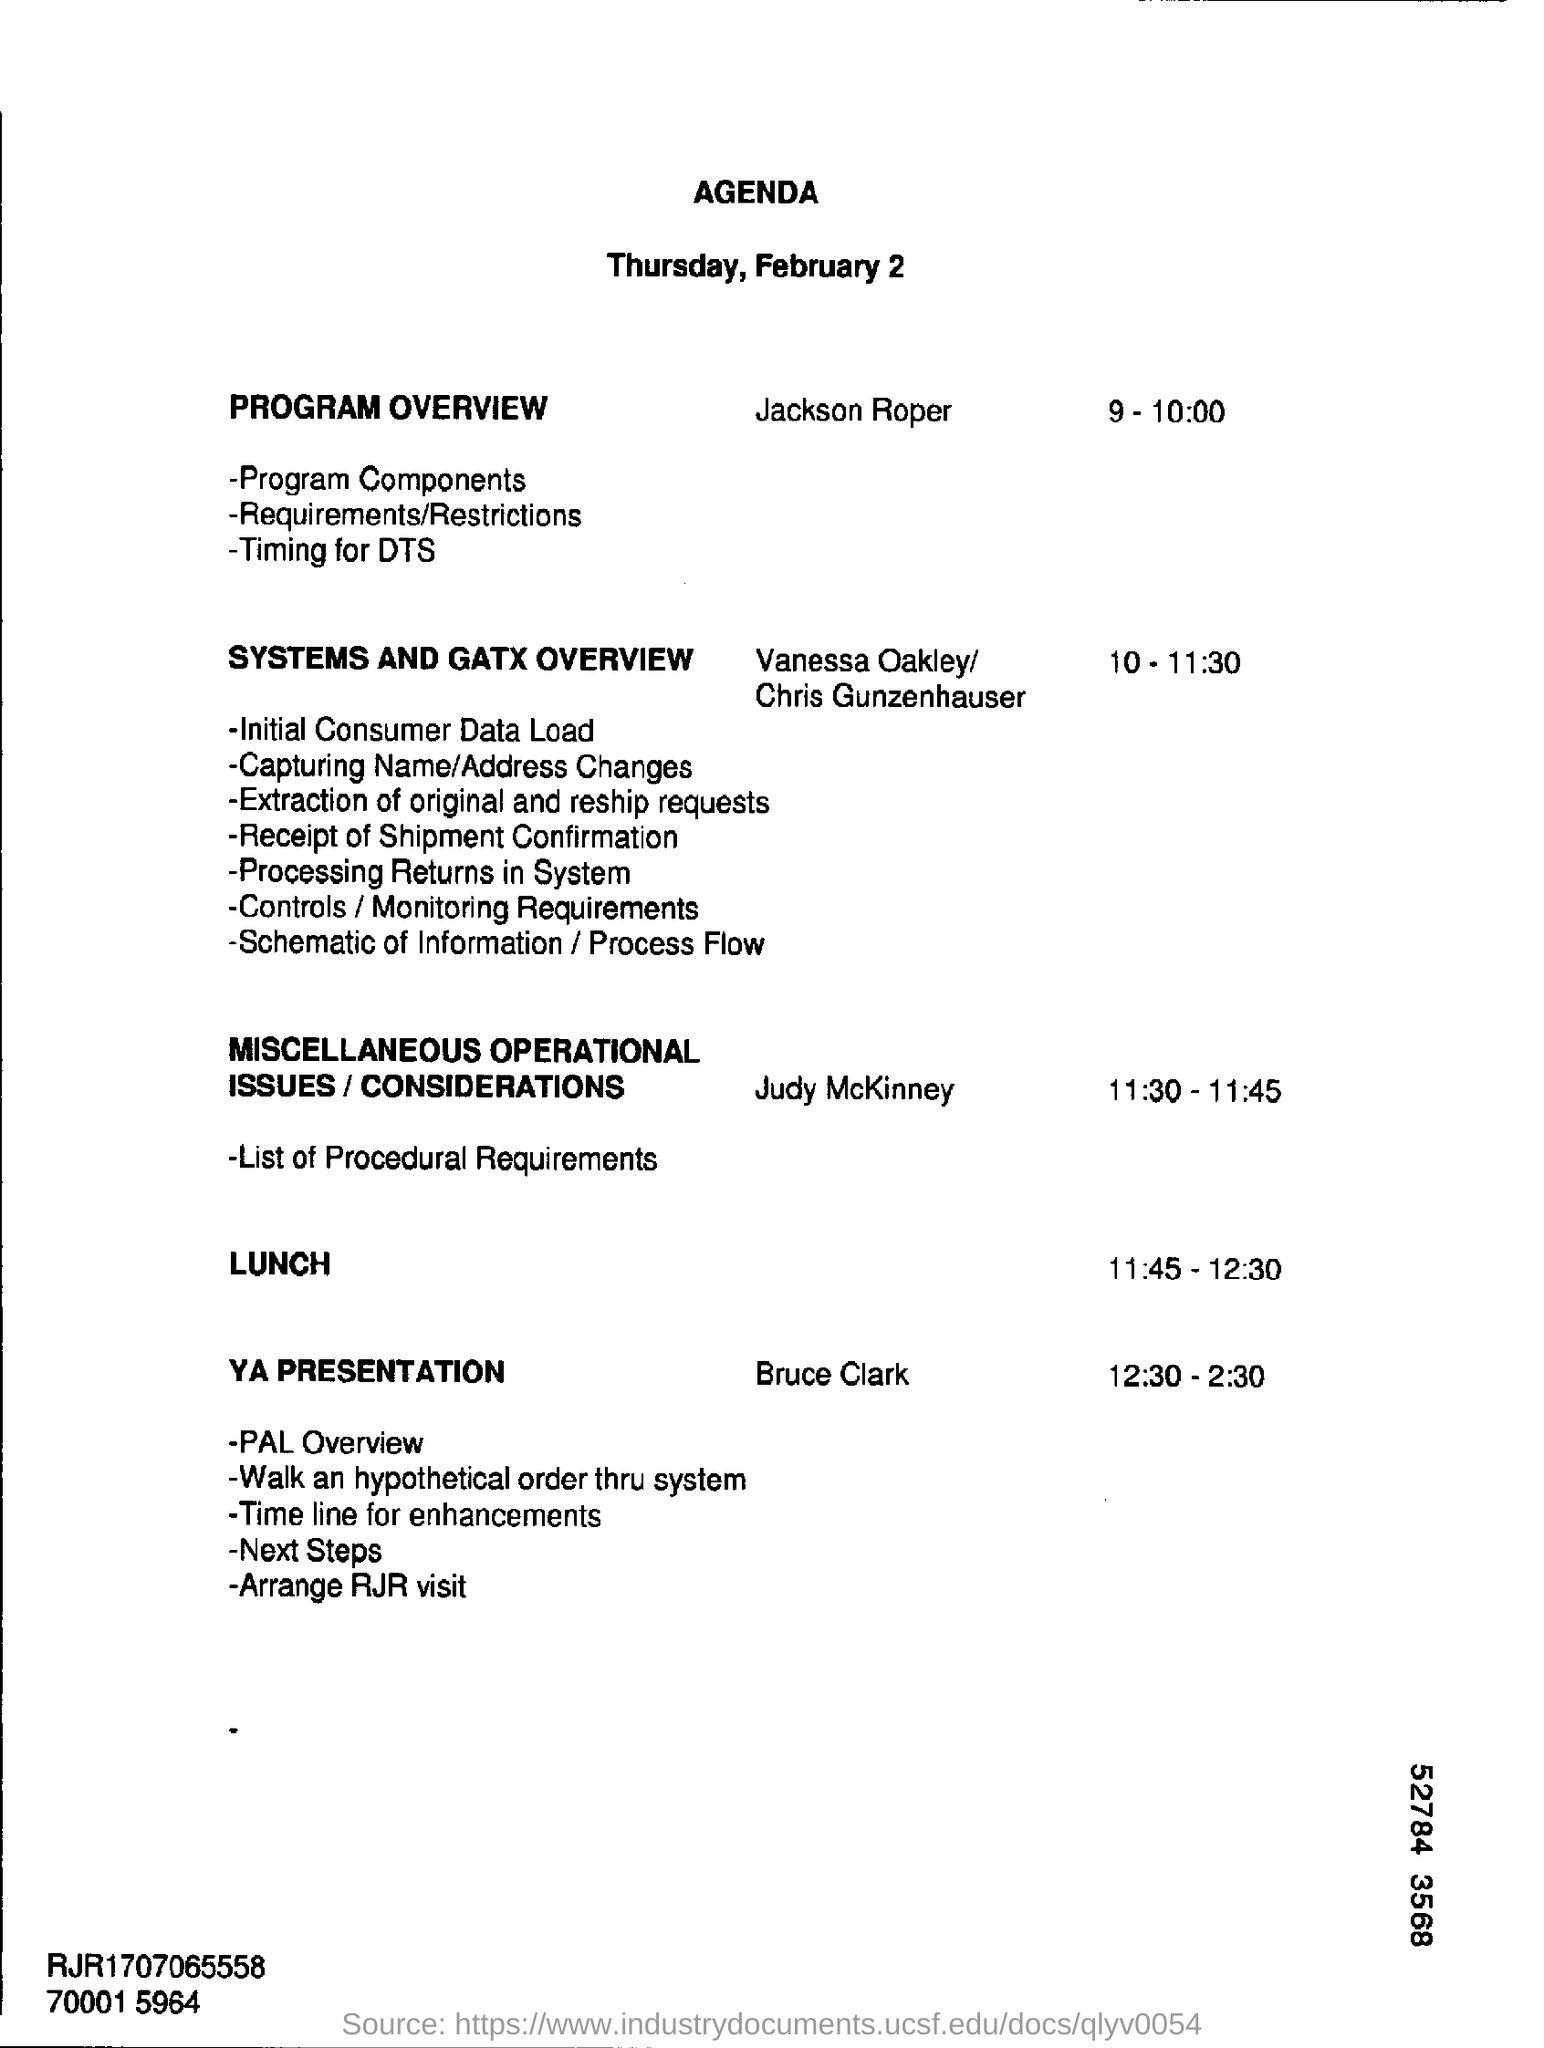List a handful of essential elements in this visual. Jackson Roper will be the individual responsible for presenting the program overview. 